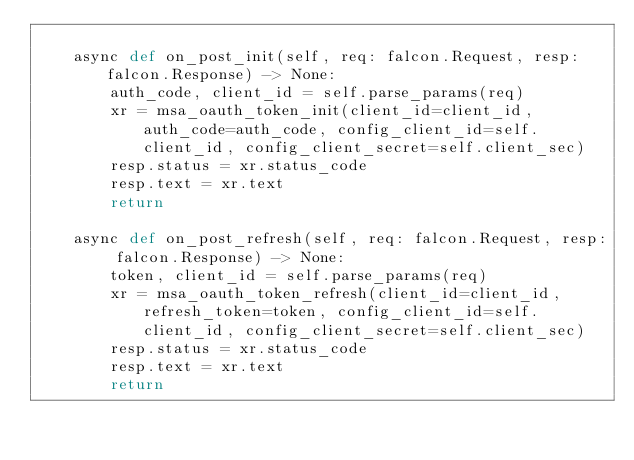<code> <loc_0><loc_0><loc_500><loc_500><_Python_>
    async def on_post_init(self, req: falcon.Request, resp: falcon.Response) -> None:
        auth_code, client_id = self.parse_params(req)
        xr = msa_oauth_token_init(client_id=client_id, auth_code=auth_code, config_client_id=self.client_id, config_client_secret=self.client_sec)
        resp.status = xr.status_code
        resp.text = xr.text
        return

    async def on_post_refresh(self, req: falcon.Request, resp: falcon.Response) -> None:
        token, client_id = self.parse_params(req)
        xr = msa_oauth_token_refresh(client_id=client_id, refresh_token=token, config_client_id=self.client_id, config_client_secret=self.client_sec)
        resp.status = xr.status_code
        resp.text = xr.text
        return
</code> 